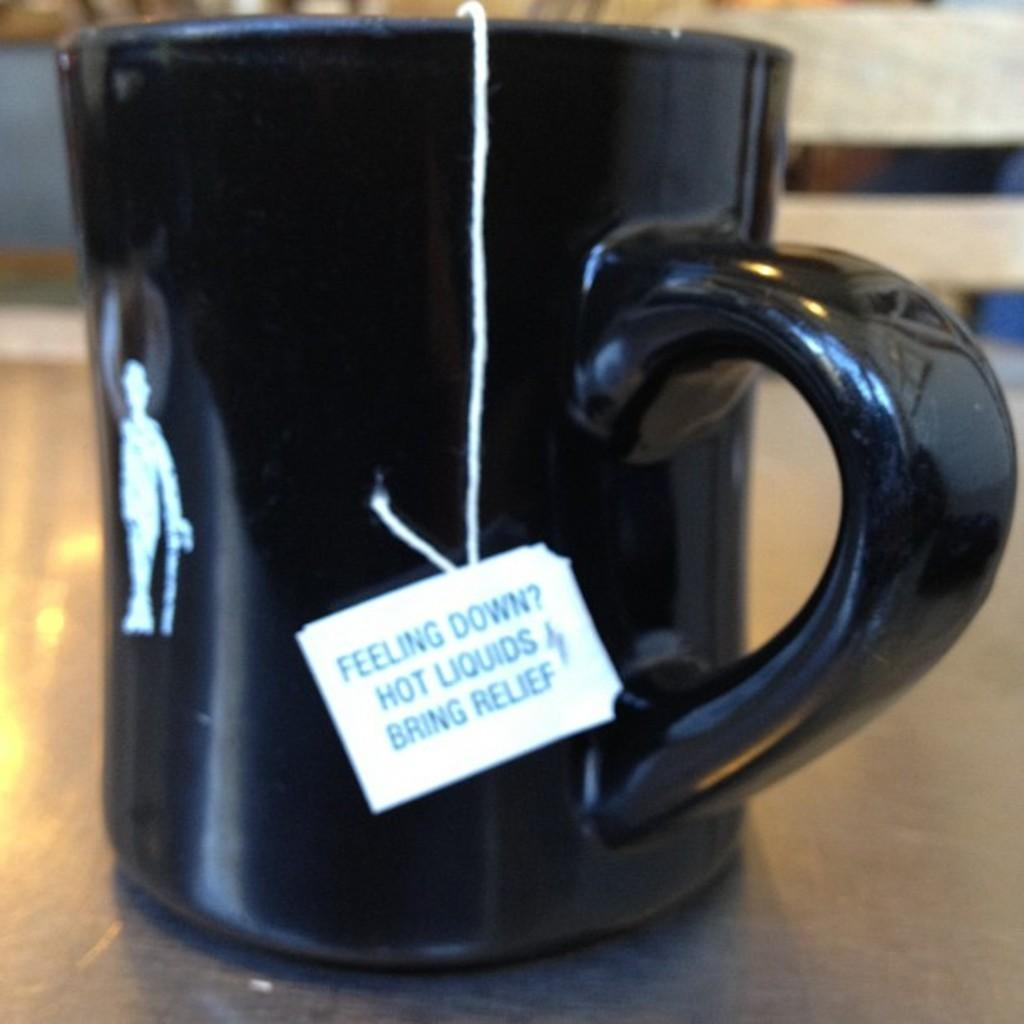<image>
Create a compact narrative representing the image presented. A black mug with a string hanging out of it that has a tag that says "Feeling Down? Hot Liquids Bring Relief". 